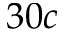<formula> <loc_0><loc_0><loc_500><loc_500>3 0 c</formula> 